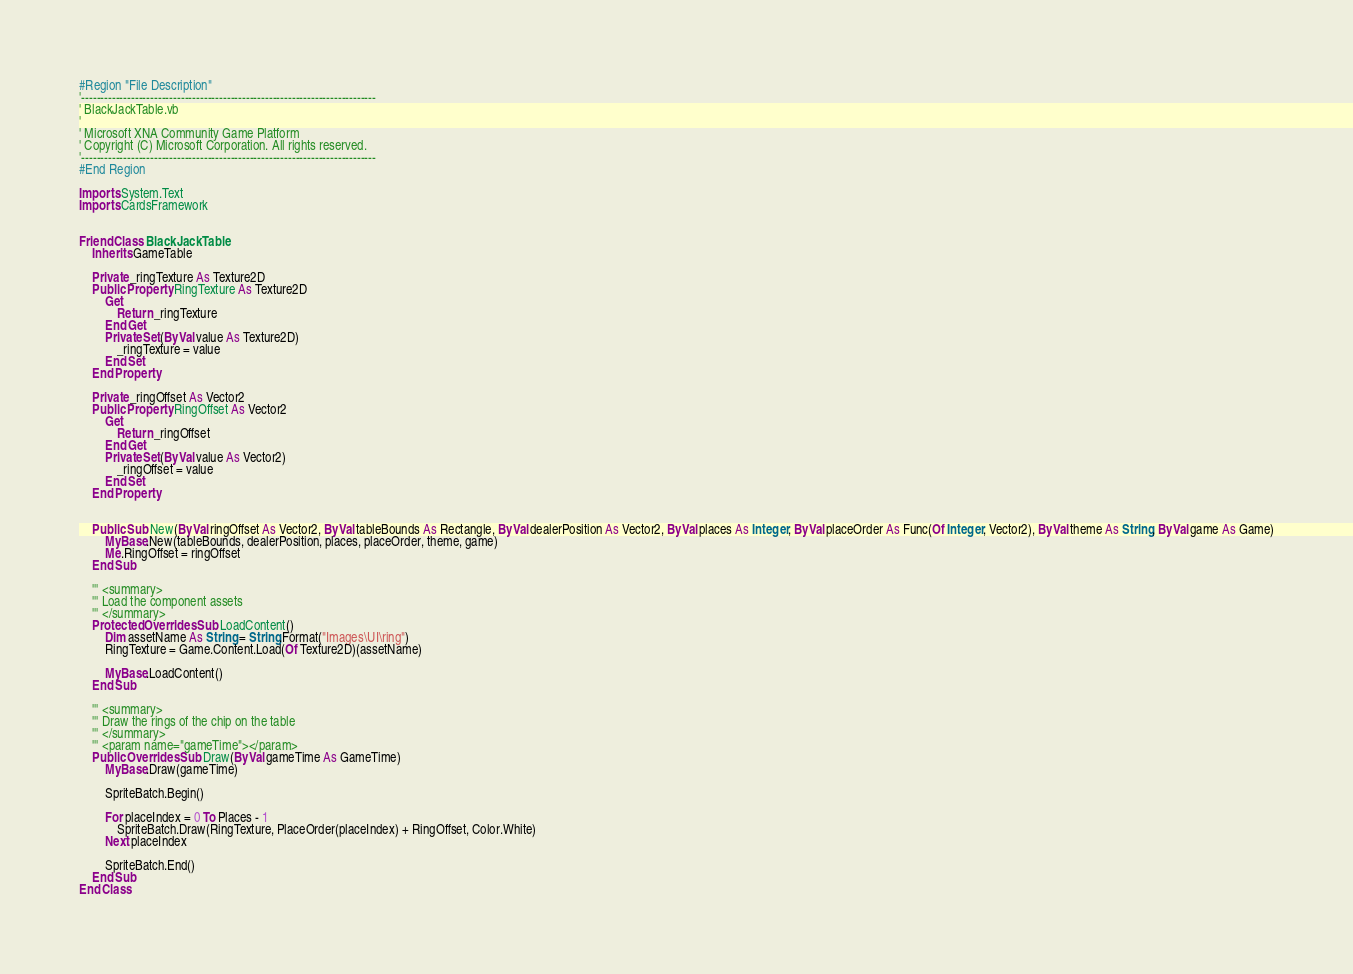Convert code to text. <code><loc_0><loc_0><loc_500><loc_500><_VisualBasic_>#Region "File Description"
'-----------------------------------------------------------------------------
' BlackJackTable.vb
'
' Microsoft XNA Community Game Platform
' Copyright (C) Microsoft Corporation. All rights reserved.
'-----------------------------------------------------------------------------
#End Region

Imports System.Text
Imports CardsFramework


Friend Class BlackJackTable
    Inherits GameTable

    Private _ringTexture As Texture2D
    Public Property RingTexture As Texture2D
        Get
            Return _ringTexture
        End Get
        Private Set(ByVal value As Texture2D)
            _ringTexture = value
        End Set
    End Property

    Private _ringOffset As Vector2
    Public Property RingOffset As Vector2
        Get
            Return _ringOffset
        End Get
        Private Set(ByVal value As Vector2)
            _ringOffset = value
        End Set
    End Property


    Public Sub New(ByVal ringOffset As Vector2, ByVal tableBounds As Rectangle, ByVal dealerPosition As Vector2, ByVal places As Integer, ByVal placeOrder As Func(Of Integer, Vector2), ByVal theme As String, ByVal game As Game)
        MyBase.New(tableBounds, dealerPosition, places, placeOrder, theme, game)
        Me.RingOffset = ringOffset
    End Sub

    ''' <summary>
    ''' Load the component assets
    ''' </summary>
    Protected Overrides Sub LoadContent()
        Dim assetName As String = String.Format("Images\UI\ring")
        RingTexture = Game.Content.Load(Of Texture2D)(assetName)

        MyBase.LoadContent()
    End Sub

    ''' <summary>
    ''' Draw the rings of the chip on the table
    ''' </summary>
    ''' <param name="gameTime"></param>
    Public Overrides Sub Draw(ByVal gameTime As GameTime)
        MyBase.Draw(gameTime)

        SpriteBatch.Begin()

        For placeIndex = 0 To Places - 1
            SpriteBatch.Draw(RingTexture, PlaceOrder(placeIndex) + RingOffset, Color.White)
        Next placeIndex

        SpriteBatch.End()
    End Sub
End Class
</code> 